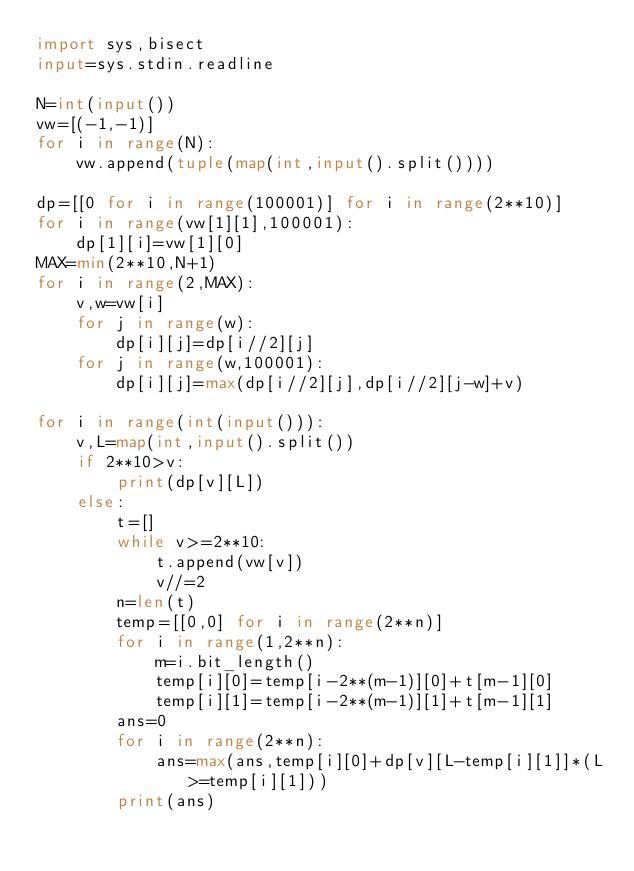<code> <loc_0><loc_0><loc_500><loc_500><_Python_>import sys,bisect
input=sys.stdin.readline

N=int(input())
vw=[(-1,-1)]
for i in range(N):
    vw.append(tuple(map(int,input().split())))

dp=[[0 for i in range(100001)] for i in range(2**10)]
for i in range(vw[1][1],100001):
    dp[1][i]=vw[1][0]
MAX=min(2**10,N+1)
for i in range(2,MAX):
    v,w=vw[i]
    for j in range(w):
        dp[i][j]=dp[i//2][j]
    for j in range(w,100001):
        dp[i][j]=max(dp[i//2][j],dp[i//2][j-w]+v)

for i in range(int(input())):
    v,L=map(int,input().split())
    if 2**10>v:
        print(dp[v][L])
    else:
        t=[]
        while v>=2**10:
            t.append(vw[v])
            v//=2
        n=len(t)
        temp=[[0,0] for i in range(2**n)]
        for i in range(1,2**n):
            m=i.bit_length()
            temp[i][0]=temp[i-2**(m-1)][0]+t[m-1][0]
            temp[i][1]=temp[i-2**(m-1)][1]+t[m-1][1]
        ans=0
        for i in range(2**n):
            ans=max(ans,temp[i][0]+dp[v][L-temp[i][1]]*(L>=temp[i][1]))
        print(ans)</code> 